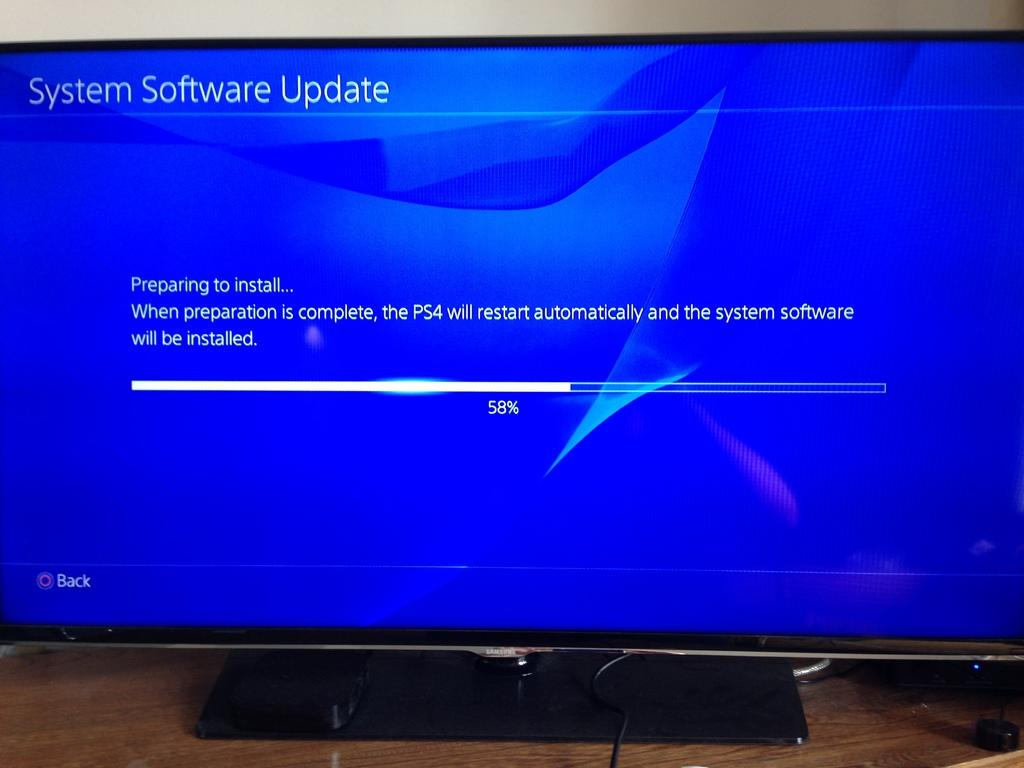<image>
Share a concise interpretation of the image provided. The computer is 58% of the way through a software update. 